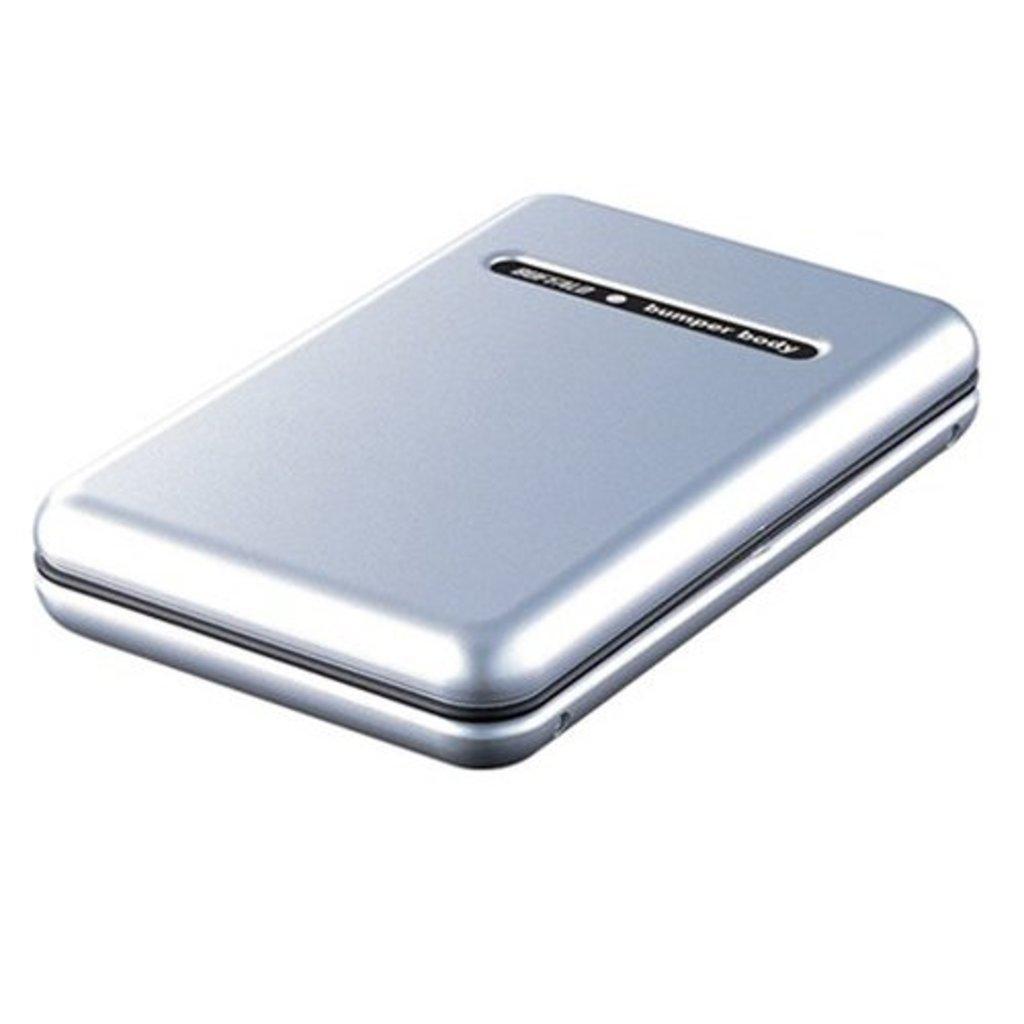What does this device say in the black part?
Offer a terse response. Bumper body. What kind of body is it?
Offer a very short reply. Bumper. 